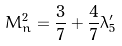<formula> <loc_0><loc_0><loc_500><loc_500>M _ { n } ^ { 2 } = \frac { 3 } { 7 } + \frac { 4 } { 7 } \lambda ^ { \prime } _ { 5 }</formula> 